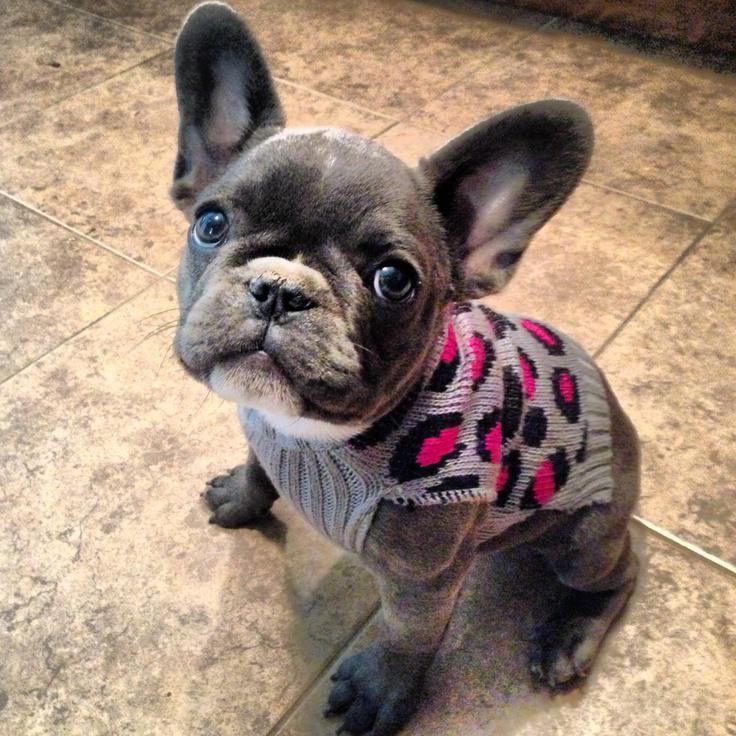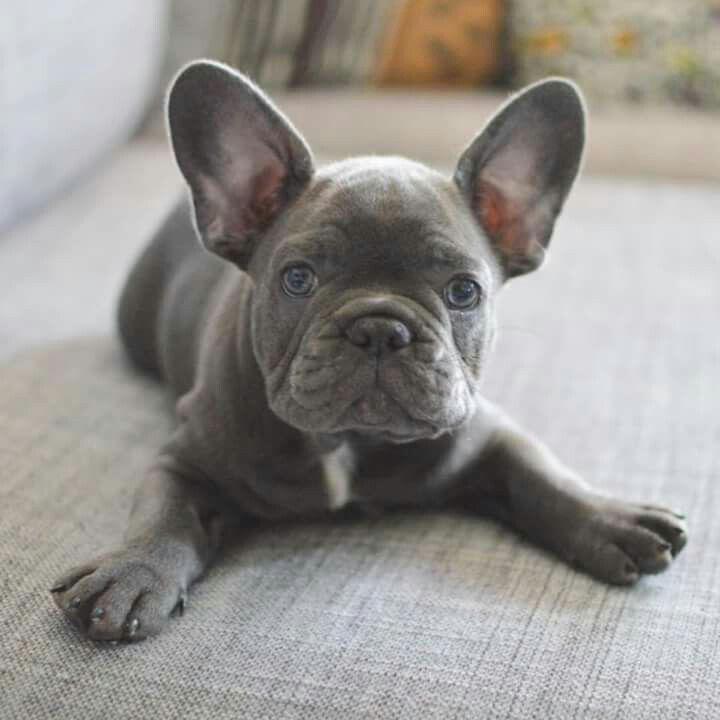The first image is the image on the left, the second image is the image on the right. Assess this claim about the two images: "An image shows exactly one gray big-eared dog, and it is wearing something.". Correct or not? Answer yes or no. Yes. 